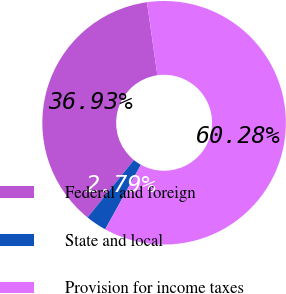Convert chart to OTSL. <chart><loc_0><loc_0><loc_500><loc_500><pie_chart><fcel>Federal and foreign<fcel>State and local<fcel>Provision for income taxes<nl><fcel>36.93%<fcel>2.79%<fcel>60.28%<nl></chart> 